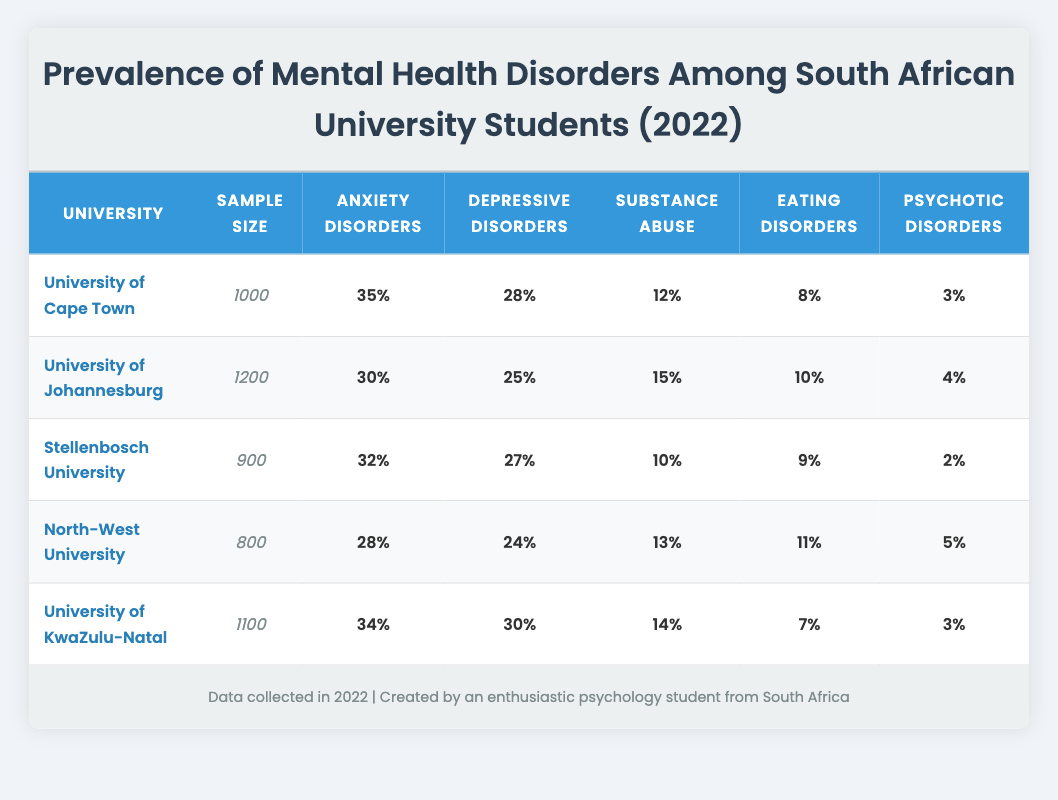What is the prevalence rate of anxiety disorders at the University of Cape Town? From the table, I can see that the prevalence rate for anxiety disorders specifically in the University of Cape Town is 35%.
Answer: 35% Which university has the highest prevalence of depressive disorders? I can compare the prevalence rates of depressive disorders across the universities. The University of KwaZulu-Natal has the highest rate at 30%.
Answer: University of KwaZulu-Natal How many students reported substance abuse at North-West University? The table states that 13% of 800 students reported substance abuse at North-West University. To find the number, I calculate: 800 * 0.13 = 104 students.
Answer: 104 What is the overall average prevalence rate of eating disorders across all five universities? To calculate the average, I sum the prevalence rates for eating disorders: 8 + 10 + 9 + 11 + 7 = 45. There are 5 universities, so the average is 45/5 = 9%.
Answer: 9% Is it true that the University of Johannesburg has a higher prevalence of psychotic disorders than Stellenbosch University? By comparing the rates from the table, I find that the University of Johannesburg has a prevalence of 4% while Stellenbosch University has 2%. Since 4% is greater than 2%, this statement is true.
Answer: Yes 